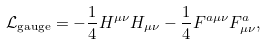<formula> <loc_0><loc_0><loc_500><loc_500>\mathcal { L } _ { \text {gauge} } = - \frac { 1 } { 4 } H ^ { \mu \nu } H _ { \mu \nu } - \frac { 1 } { 4 } F ^ { a \mu \nu } F ^ { a } _ { \mu \nu } ,</formula> 